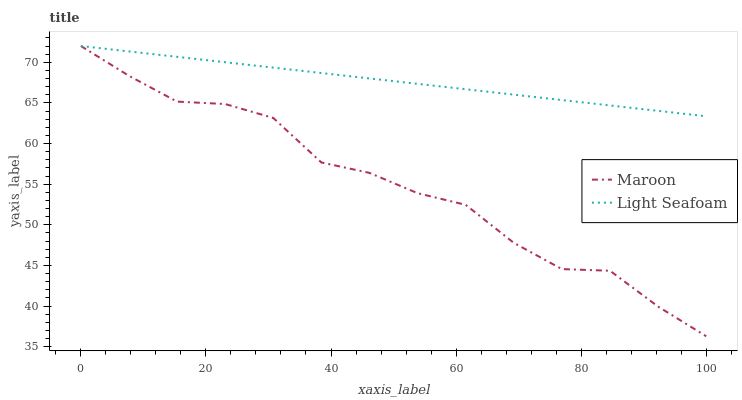Does Maroon have the minimum area under the curve?
Answer yes or no. Yes. Does Light Seafoam have the maximum area under the curve?
Answer yes or no. Yes. Does Maroon have the maximum area under the curve?
Answer yes or no. No. Is Light Seafoam the smoothest?
Answer yes or no. Yes. Is Maroon the roughest?
Answer yes or no. Yes. Is Maroon the smoothest?
Answer yes or no. No. Does Maroon have the lowest value?
Answer yes or no. Yes. Does Maroon have the highest value?
Answer yes or no. Yes. Does Light Seafoam intersect Maroon?
Answer yes or no. Yes. Is Light Seafoam less than Maroon?
Answer yes or no. No. Is Light Seafoam greater than Maroon?
Answer yes or no. No. 